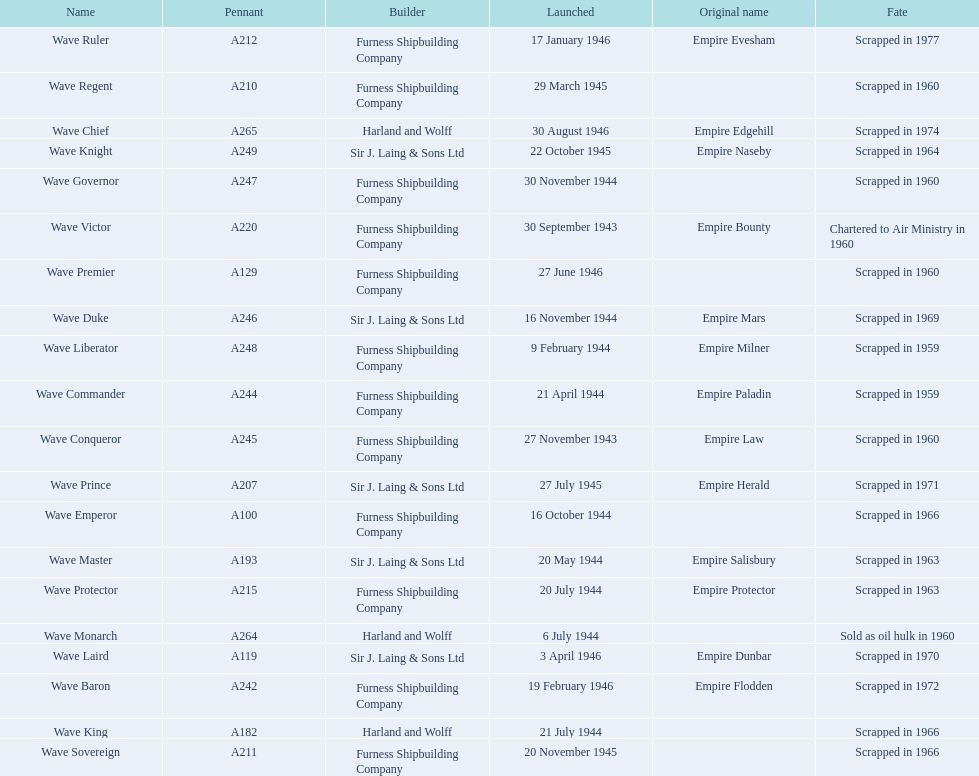How many ships were launched in the year 1944? 9. 